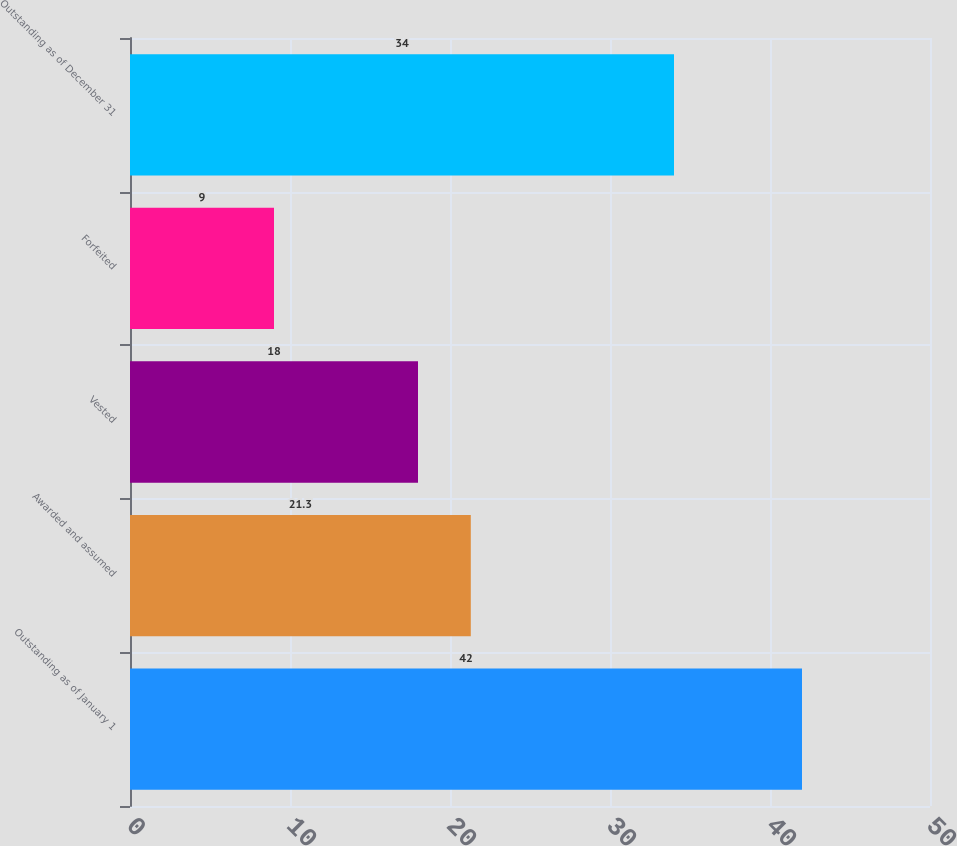Convert chart to OTSL. <chart><loc_0><loc_0><loc_500><loc_500><bar_chart><fcel>Outstanding as of January 1<fcel>Awarded and assumed<fcel>Vested<fcel>Forfeited<fcel>Outstanding as of December 31<nl><fcel>42<fcel>21.3<fcel>18<fcel>9<fcel>34<nl></chart> 